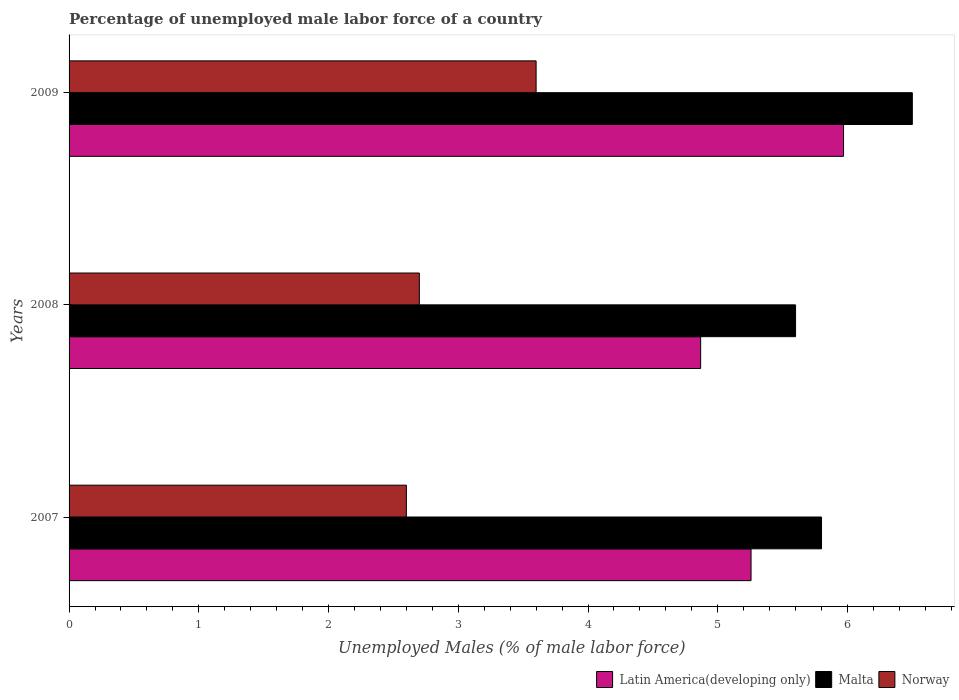How many different coloured bars are there?
Your answer should be very brief. 3. How many groups of bars are there?
Your answer should be compact. 3. How many bars are there on the 3rd tick from the top?
Keep it short and to the point. 3. How many bars are there on the 1st tick from the bottom?
Provide a short and direct response. 3. What is the percentage of unemployed male labor force in Latin America(developing only) in 2007?
Make the answer very short. 5.26. Across all years, what is the maximum percentage of unemployed male labor force in Latin America(developing only)?
Give a very brief answer. 5.97. Across all years, what is the minimum percentage of unemployed male labor force in Norway?
Provide a succinct answer. 2.6. In which year was the percentage of unemployed male labor force in Malta maximum?
Keep it short and to the point. 2009. What is the total percentage of unemployed male labor force in Latin America(developing only) in the graph?
Offer a very short reply. 16.09. What is the difference between the percentage of unemployed male labor force in Latin America(developing only) in 2007 and that in 2009?
Provide a succinct answer. -0.71. What is the difference between the percentage of unemployed male labor force in Latin America(developing only) in 2009 and the percentage of unemployed male labor force in Malta in 2008?
Make the answer very short. 0.37. What is the average percentage of unemployed male labor force in Norway per year?
Provide a short and direct response. 2.97. In the year 2007, what is the difference between the percentage of unemployed male labor force in Norway and percentage of unemployed male labor force in Malta?
Provide a succinct answer. -3.2. What is the ratio of the percentage of unemployed male labor force in Latin America(developing only) in 2007 to that in 2009?
Make the answer very short. 0.88. Is the percentage of unemployed male labor force in Latin America(developing only) in 2007 less than that in 2009?
Your answer should be compact. Yes. What is the difference between the highest and the second highest percentage of unemployed male labor force in Norway?
Provide a short and direct response. 0.9. What is the difference between the highest and the lowest percentage of unemployed male labor force in Norway?
Offer a terse response. 1. What does the 1st bar from the bottom in 2008 represents?
Your answer should be very brief. Latin America(developing only). Is it the case that in every year, the sum of the percentage of unemployed male labor force in Latin America(developing only) and percentage of unemployed male labor force in Norway is greater than the percentage of unemployed male labor force in Malta?
Provide a succinct answer. Yes. How many bars are there?
Make the answer very short. 9. Are all the bars in the graph horizontal?
Offer a terse response. Yes. How many years are there in the graph?
Make the answer very short. 3. Are the values on the major ticks of X-axis written in scientific E-notation?
Give a very brief answer. No. Does the graph contain any zero values?
Ensure brevity in your answer.  No. How many legend labels are there?
Ensure brevity in your answer.  3. What is the title of the graph?
Give a very brief answer. Percentage of unemployed male labor force of a country. What is the label or title of the X-axis?
Provide a short and direct response. Unemployed Males (% of male labor force). What is the label or title of the Y-axis?
Provide a short and direct response. Years. What is the Unemployed Males (% of male labor force) of Latin America(developing only) in 2007?
Give a very brief answer. 5.26. What is the Unemployed Males (% of male labor force) of Malta in 2007?
Keep it short and to the point. 5.8. What is the Unemployed Males (% of male labor force) of Norway in 2007?
Ensure brevity in your answer.  2.6. What is the Unemployed Males (% of male labor force) of Latin America(developing only) in 2008?
Your answer should be very brief. 4.87. What is the Unemployed Males (% of male labor force) of Malta in 2008?
Make the answer very short. 5.6. What is the Unemployed Males (% of male labor force) in Norway in 2008?
Offer a very short reply. 2.7. What is the Unemployed Males (% of male labor force) of Latin America(developing only) in 2009?
Make the answer very short. 5.97. What is the Unemployed Males (% of male labor force) in Norway in 2009?
Keep it short and to the point. 3.6. Across all years, what is the maximum Unemployed Males (% of male labor force) of Latin America(developing only)?
Ensure brevity in your answer.  5.97. Across all years, what is the maximum Unemployed Males (% of male labor force) in Malta?
Offer a very short reply. 6.5. Across all years, what is the maximum Unemployed Males (% of male labor force) in Norway?
Your answer should be very brief. 3.6. Across all years, what is the minimum Unemployed Males (% of male labor force) in Latin America(developing only)?
Provide a short and direct response. 4.87. Across all years, what is the minimum Unemployed Males (% of male labor force) of Malta?
Your response must be concise. 5.6. Across all years, what is the minimum Unemployed Males (% of male labor force) of Norway?
Your answer should be compact. 2.6. What is the total Unemployed Males (% of male labor force) of Latin America(developing only) in the graph?
Your answer should be very brief. 16.09. What is the difference between the Unemployed Males (% of male labor force) of Latin America(developing only) in 2007 and that in 2008?
Your answer should be compact. 0.39. What is the difference between the Unemployed Males (% of male labor force) in Latin America(developing only) in 2007 and that in 2009?
Offer a terse response. -0.71. What is the difference between the Unemployed Males (% of male labor force) in Malta in 2007 and that in 2009?
Keep it short and to the point. -0.7. What is the difference between the Unemployed Males (% of male labor force) of Norway in 2007 and that in 2009?
Your answer should be very brief. -1. What is the difference between the Unemployed Males (% of male labor force) in Latin America(developing only) in 2008 and that in 2009?
Your response must be concise. -1.1. What is the difference between the Unemployed Males (% of male labor force) of Latin America(developing only) in 2007 and the Unemployed Males (% of male labor force) of Malta in 2008?
Provide a succinct answer. -0.34. What is the difference between the Unemployed Males (% of male labor force) in Latin America(developing only) in 2007 and the Unemployed Males (% of male labor force) in Norway in 2008?
Offer a terse response. 2.56. What is the difference between the Unemployed Males (% of male labor force) of Malta in 2007 and the Unemployed Males (% of male labor force) of Norway in 2008?
Your answer should be very brief. 3.1. What is the difference between the Unemployed Males (% of male labor force) in Latin America(developing only) in 2007 and the Unemployed Males (% of male labor force) in Malta in 2009?
Your answer should be compact. -1.24. What is the difference between the Unemployed Males (% of male labor force) of Latin America(developing only) in 2007 and the Unemployed Males (% of male labor force) of Norway in 2009?
Ensure brevity in your answer.  1.66. What is the difference between the Unemployed Males (% of male labor force) in Malta in 2007 and the Unemployed Males (% of male labor force) in Norway in 2009?
Keep it short and to the point. 2.2. What is the difference between the Unemployed Males (% of male labor force) of Latin America(developing only) in 2008 and the Unemployed Males (% of male labor force) of Malta in 2009?
Your answer should be very brief. -1.63. What is the difference between the Unemployed Males (% of male labor force) in Latin America(developing only) in 2008 and the Unemployed Males (% of male labor force) in Norway in 2009?
Your answer should be compact. 1.27. What is the difference between the Unemployed Males (% of male labor force) of Malta in 2008 and the Unemployed Males (% of male labor force) of Norway in 2009?
Make the answer very short. 2. What is the average Unemployed Males (% of male labor force) of Latin America(developing only) per year?
Your answer should be compact. 5.36. What is the average Unemployed Males (% of male labor force) in Malta per year?
Make the answer very short. 5.97. What is the average Unemployed Males (% of male labor force) of Norway per year?
Your answer should be very brief. 2.97. In the year 2007, what is the difference between the Unemployed Males (% of male labor force) of Latin America(developing only) and Unemployed Males (% of male labor force) of Malta?
Keep it short and to the point. -0.54. In the year 2007, what is the difference between the Unemployed Males (% of male labor force) of Latin America(developing only) and Unemployed Males (% of male labor force) of Norway?
Provide a succinct answer. 2.66. In the year 2008, what is the difference between the Unemployed Males (% of male labor force) of Latin America(developing only) and Unemployed Males (% of male labor force) of Malta?
Your answer should be compact. -0.73. In the year 2008, what is the difference between the Unemployed Males (% of male labor force) of Latin America(developing only) and Unemployed Males (% of male labor force) of Norway?
Your response must be concise. 2.17. In the year 2008, what is the difference between the Unemployed Males (% of male labor force) in Malta and Unemployed Males (% of male labor force) in Norway?
Your answer should be very brief. 2.9. In the year 2009, what is the difference between the Unemployed Males (% of male labor force) of Latin America(developing only) and Unemployed Males (% of male labor force) of Malta?
Make the answer very short. -0.53. In the year 2009, what is the difference between the Unemployed Males (% of male labor force) in Latin America(developing only) and Unemployed Males (% of male labor force) in Norway?
Ensure brevity in your answer.  2.37. In the year 2009, what is the difference between the Unemployed Males (% of male labor force) in Malta and Unemployed Males (% of male labor force) in Norway?
Offer a very short reply. 2.9. What is the ratio of the Unemployed Males (% of male labor force) in Latin America(developing only) in 2007 to that in 2008?
Your answer should be very brief. 1.08. What is the ratio of the Unemployed Males (% of male labor force) of Malta in 2007 to that in 2008?
Offer a very short reply. 1.04. What is the ratio of the Unemployed Males (% of male labor force) in Latin America(developing only) in 2007 to that in 2009?
Your response must be concise. 0.88. What is the ratio of the Unemployed Males (% of male labor force) in Malta in 2007 to that in 2009?
Keep it short and to the point. 0.89. What is the ratio of the Unemployed Males (% of male labor force) of Norway in 2007 to that in 2009?
Make the answer very short. 0.72. What is the ratio of the Unemployed Males (% of male labor force) of Latin America(developing only) in 2008 to that in 2009?
Your answer should be compact. 0.82. What is the ratio of the Unemployed Males (% of male labor force) in Malta in 2008 to that in 2009?
Provide a succinct answer. 0.86. What is the ratio of the Unemployed Males (% of male labor force) of Norway in 2008 to that in 2009?
Provide a succinct answer. 0.75. What is the difference between the highest and the second highest Unemployed Males (% of male labor force) in Latin America(developing only)?
Your answer should be compact. 0.71. What is the difference between the highest and the second highest Unemployed Males (% of male labor force) in Malta?
Ensure brevity in your answer.  0.7. What is the difference between the highest and the lowest Unemployed Males (% of male labor force) of Latin America(developing only)?
Your answer should be compact. 1.1. 